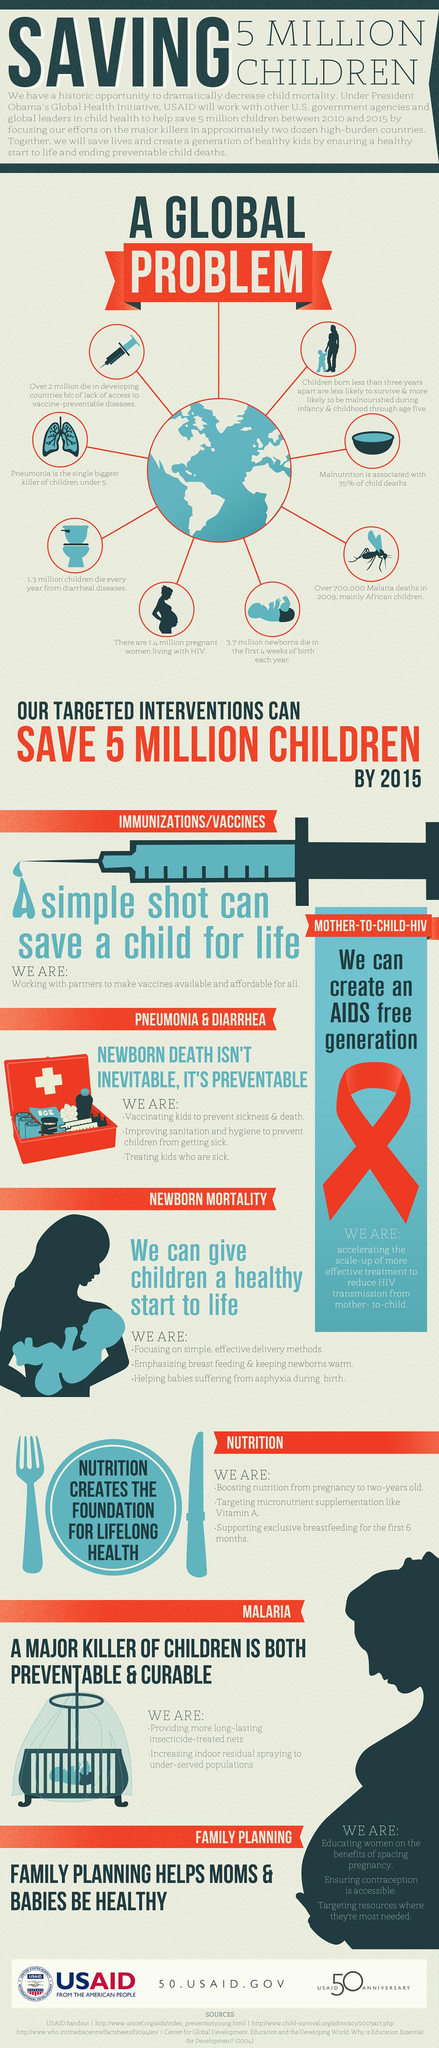Give some essential details in this illustration. It is estimated that malnutrition is responsible for 35% of infant deaths worldwide. The use of insecticide treated nets and indoor residual spraying can prevent the spread of malaria, a disease that can be life-threatening if left untreated. Immunization, sanitation, and timely medical treatment can prevent newborn deaths. The disease spread by mosquitoes mentioned in the graphic is malaria. HIV, a virus that can be transmitted from mother to child, is a highly infectious disease that affects millions of people worldwide. 